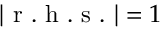Convert formula to latex. <formula><loc_0><loc_0><loc_500><loc_500>| r . h . s . | = 1</formula> 